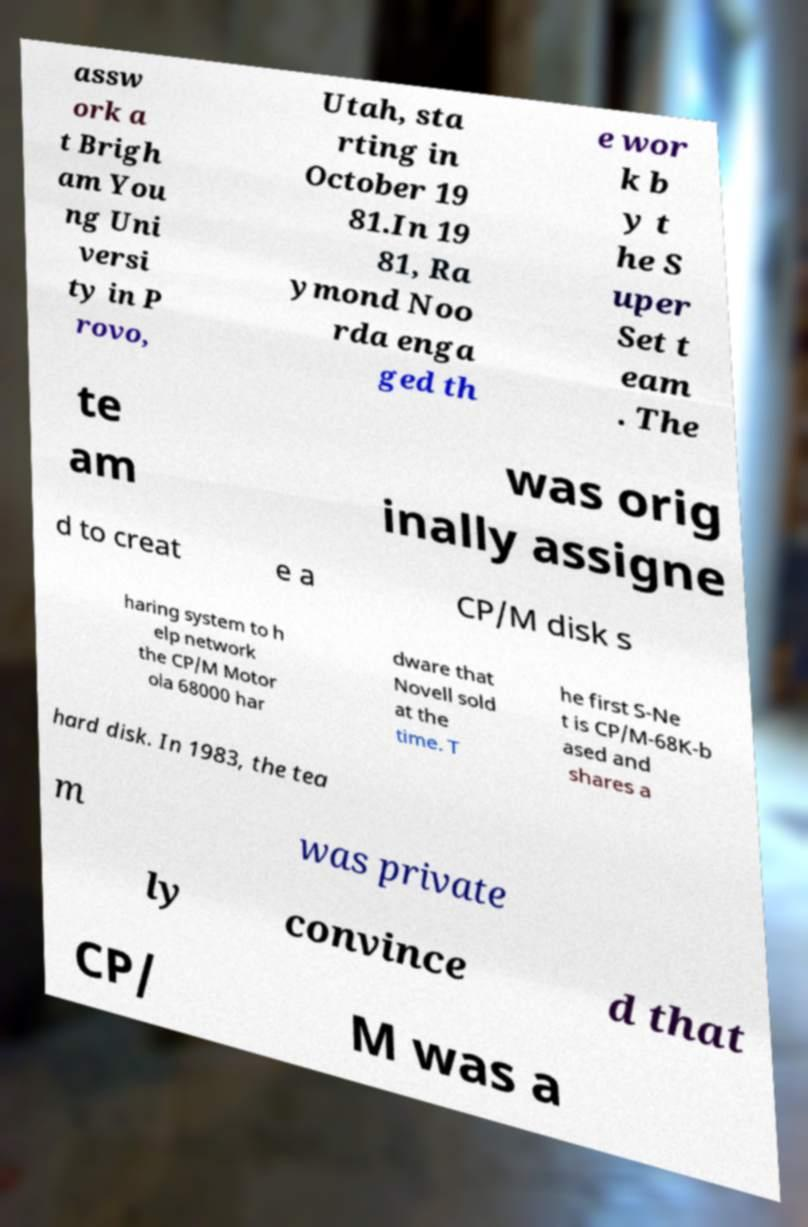Please identify and transcribe the text found in this image. assw ork a t Brigh am You ng Uni versi ty in P rovo, Utah, sta rting in October 19 81.In 19 81, Ra ymond Noo rda enga ged th e wor k b y t he S uper Set t eam . The te am was orig inally assigne d to creat e a CP/M disk s haring system to h elp network the CP/M Motor ola 68000 har dware that Novell sold at the time. T he first S-Ne t is CP/M-68K-b ased and shares a hard disk. In 1983, the tea m was private ly convince d that CP/ M was a 